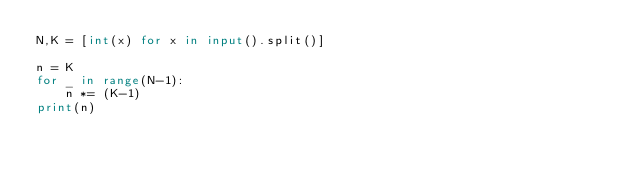Convert code to text. <code><loc_0><loc_0><loc_500><loc_500><_Python_>N,K = [int(x) for x in input().split()]

n = K
for _ in range(N-1):
    n *= (K-1)
print(n)</code> 